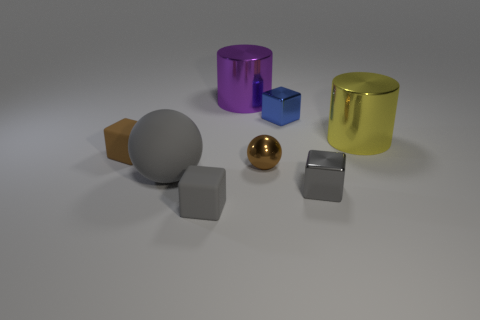Describe the atmosphere or mood that this arrangement of objects might convey. The arrangement of objects conveys a clean and orderly atmosphere, with a balanced, almost clinical composition. The soft lighting and neutral background suggest a calm and controlled setting, perfect for analytical or scientific observation. 